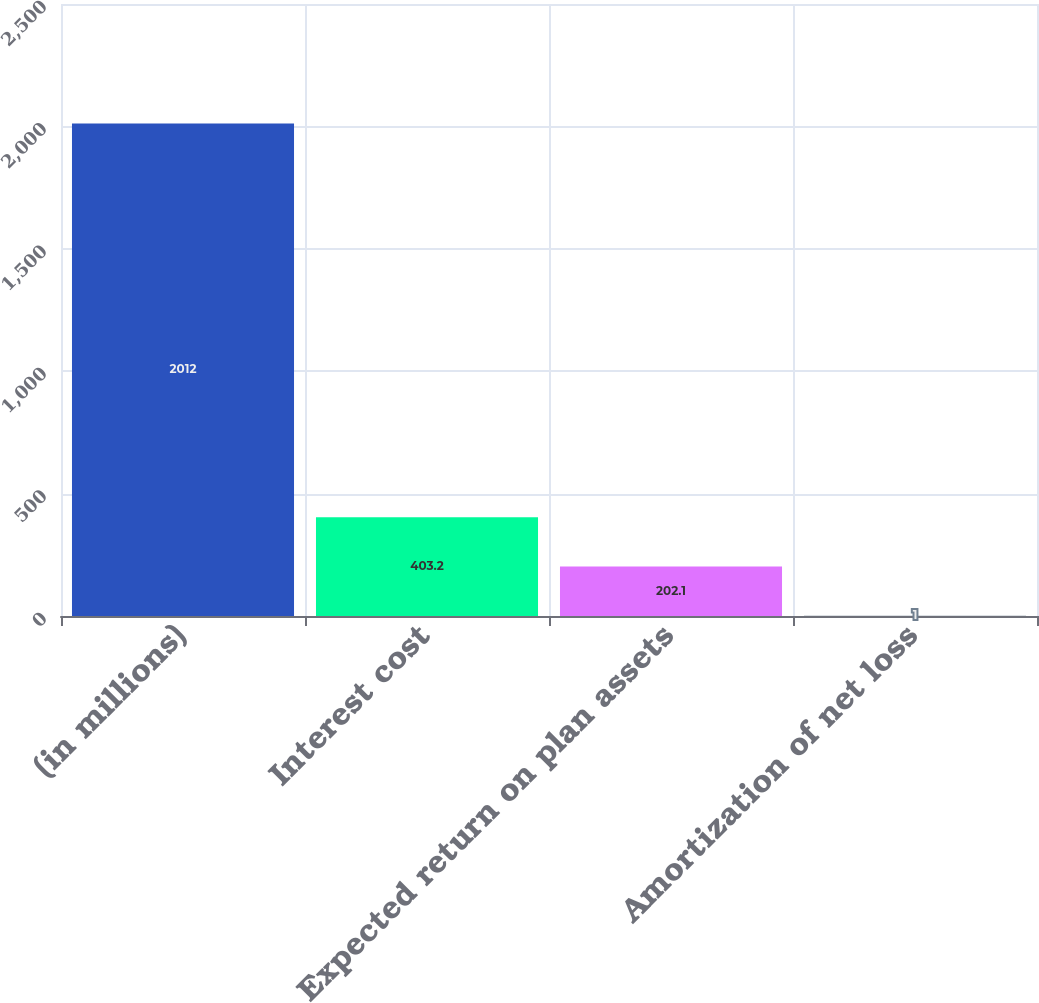Convert chart to OTSL. <chart><loc_0><loc_0><loc_500><loc_500><bar_chart><fcel>(in millions)<fcel>Interest cost<fcel>Expected return on plan assets<fcel>Amortization of net loss<nl><fcel>2012<fcel>403.2<fcel>202.1<fcel>1<nl></chart> 